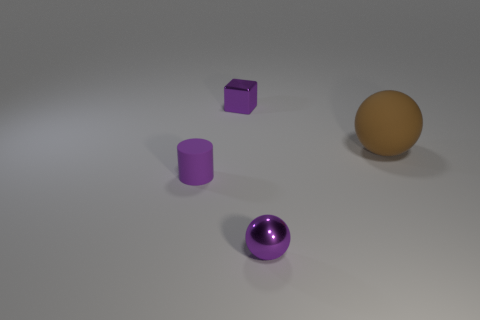There is a small metal object on the left side of the tiny metallic object in front of the large object; are there any small objects that are right of it?
Make the answer very short. Yes. Is there a object of the same size as the purple cylinder?
Keep it short and to the point. Yes. What is the material of the purple cube that is the same size as the shiny ball?
Make the answer very short. Metal. There is a purple metal sphere; is it the same size as the thing behind the large object?
Offer a terse response. Yes. What number of rubber objects are tiny spheres or small cubes?
Your response must be concise. 0. What number of small shiny things are the same shape as the big brown thing?
Offer a terse response. 1. There is a small cube that is the same color as the cylinder; what is its material?
Your response must be concise. Metal. There is a purple object behind the brown sphere; is it the same size as the thing left of the purple shiny block?
Make the answer very short. Yes. The thing right of the small purple ball has what shape?
Your answer should be very brief. Sphere. What material is the other small thing that is the same shape as the brown object?
Ensure brevity in your answer.  Metal. 